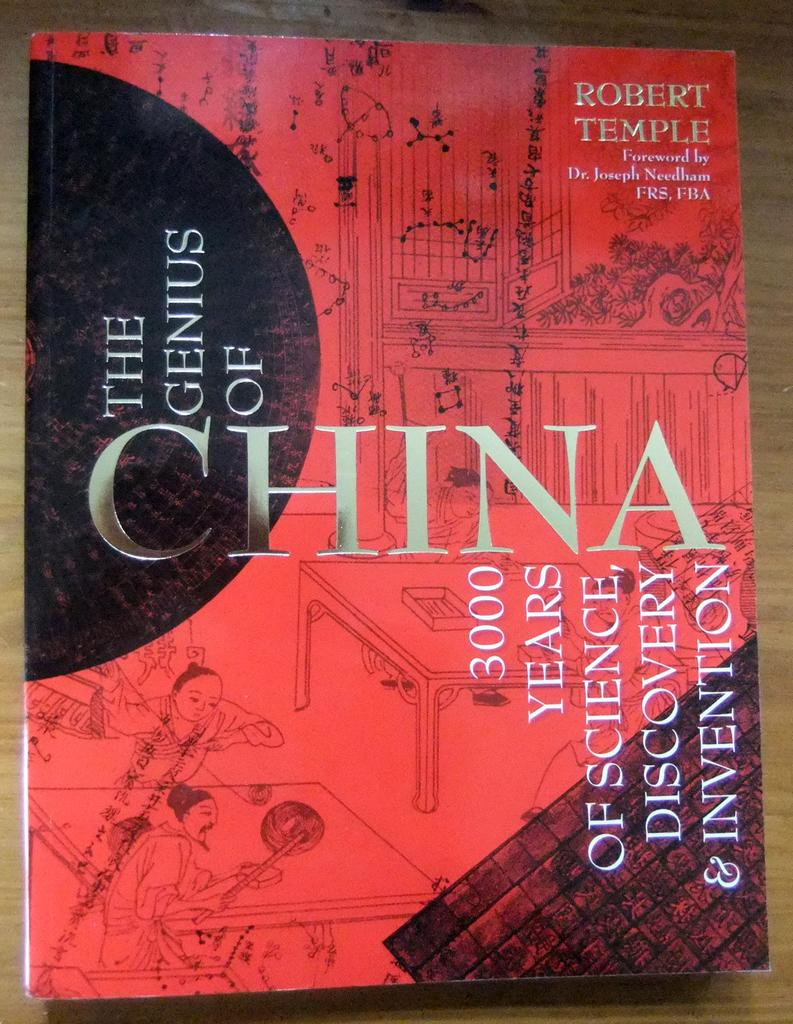<image>
Give a short and clear explanation of the subsequent image. A red book called The Genius of China is on a wooden table. 